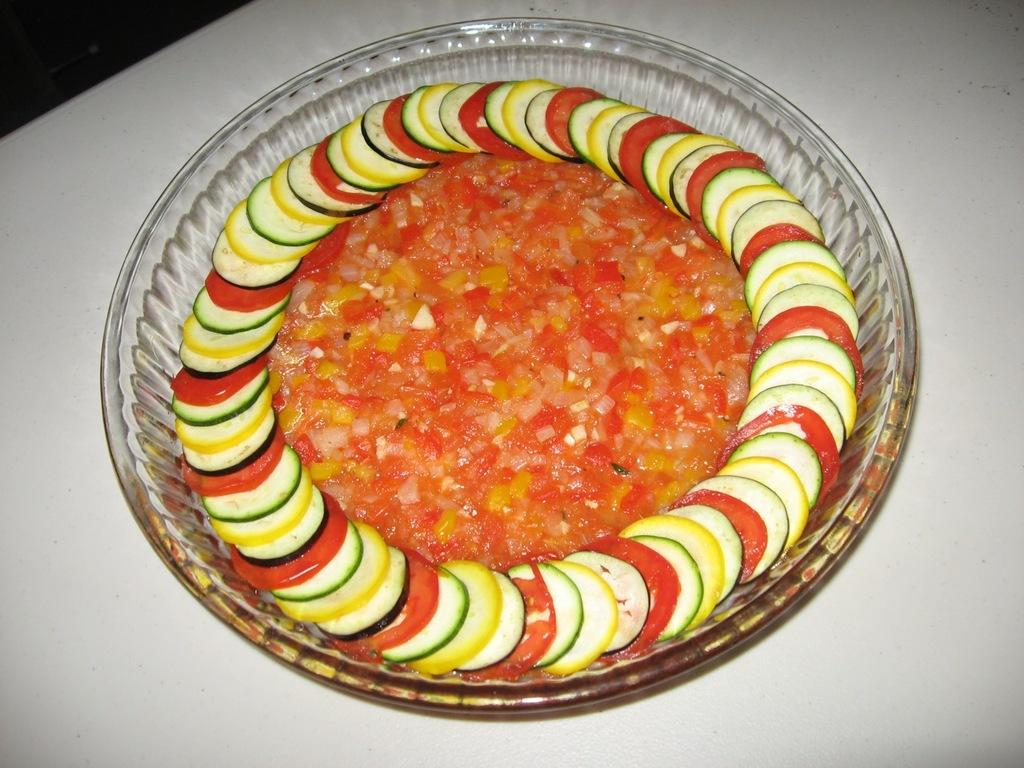What is the main object in the image? There is a glass bowl in the image. What is inside the glass bowl? The glass bowl contains different types of food. Where is the lock on the glass bowl in the image? There is no lock present on the glass bowl in the image. What type of shop can be seen in the background of the image? There is no shop visible in the image; it only features a glass bowl containing different types of food. 